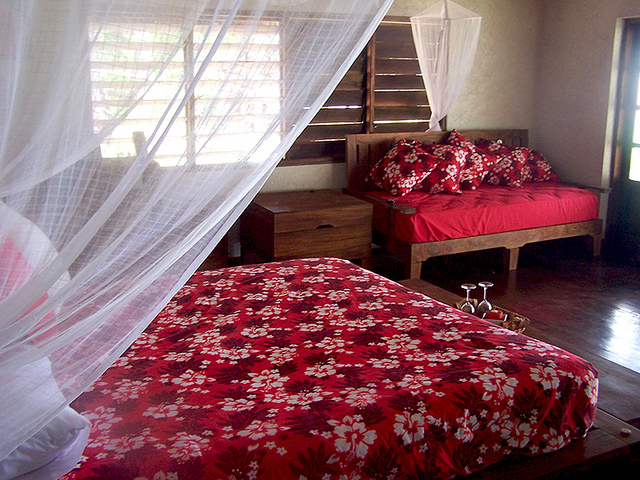What does the presence of mosquito nets imply about the location? The presence of mosquito nets typically points to a location prone to mosquitoes, possibly in a tropical or subtropical region where insect-borne diseases might be a concern. It also suggests a focus on keeping the sleeping area comfortable and bug-free, which is especially important in such environments. 